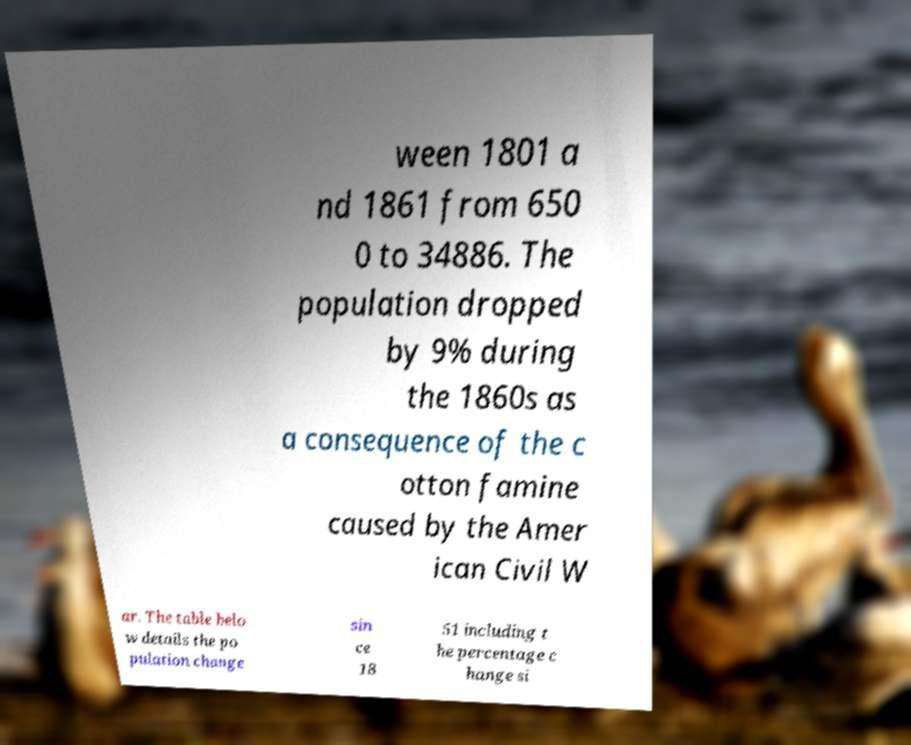Could you extract and type out the text from this image? ween 1801 a nd 1861 from 650 0 to 34886. The population dropped by 9% during the 1860s as a consequence of the c otton famine caused by the Amer ican Civil W ar. The table belo w details the po pulation change sin ce 18 51 including t he percentage c hange si 